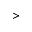<formula> <loc_0><loc_0><loc_500><loc_500>></formula> 